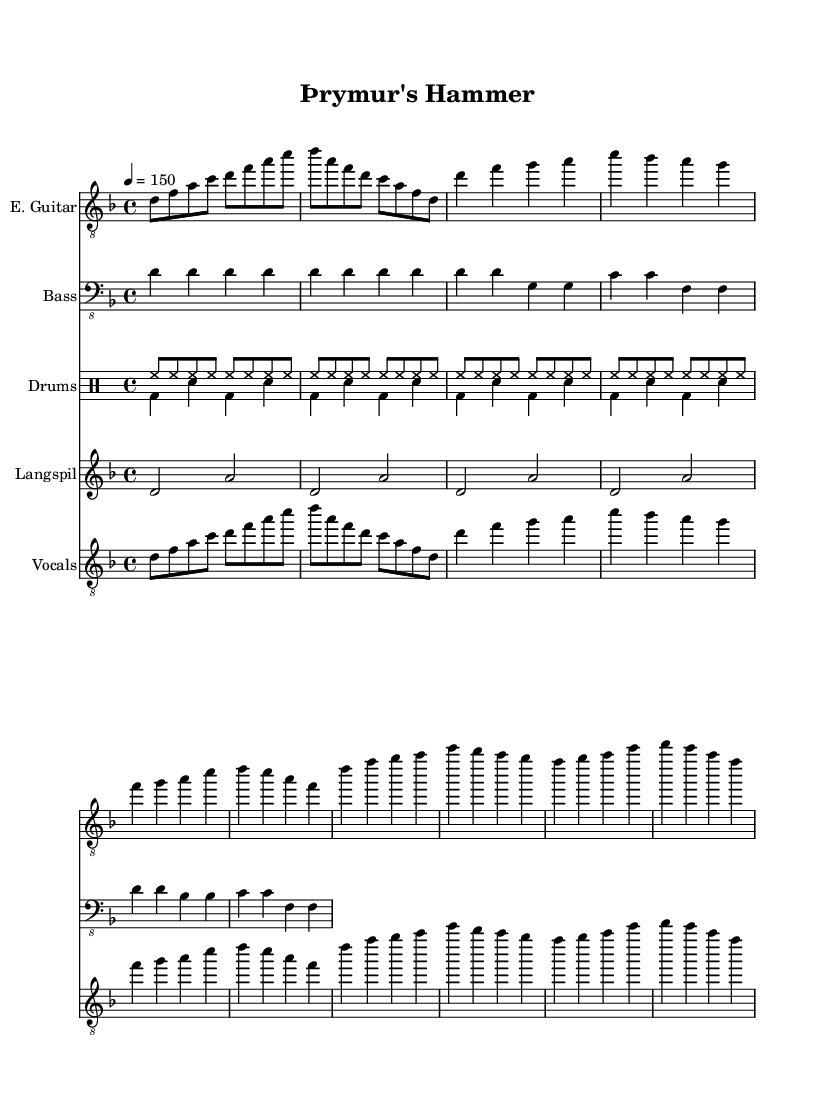What is the key signature of this music? The key signature is indicated at the beginning of the music with the sharp or flat symbols. In this case, it is D minor, which has one flat (B flat) and is noted in the header.
Answer: D minor What is the time signature of this music? The time signature is found at the beginning of the score, indicating how many beats are in each measure. Here, it shows 4/4, meaning there are four beats per measure.
Answer: 4/4 What is the tempo of the piece? The tempo marking is given in the global section, specifically indicating the beats per minute (BPM). It reads 4 = 150, meaning there are 150 beats per minute.
Answer: 150 How many measures are in the Intro section? By counting the grouped notes in the Intro section, we see that there are 4 measures total. Each measure is separated by a vertical line.
Answer: 4 What is the vocal theme of the song? The lyrics provided describe the theme of the song, which revolves around Thor and his hammer. This can be inferred from the words noted in the vocal section.
Answer: Thor's hammer What instrument is labeled "Langspil" in the score? The instrument labeled "Langspil" can be identified in the score under its respective staff. It refers to a traditional Icelandic string instrument designed for this composition.
Answer: Langspil What role does the drum pattern play in the piece? Analyzing the drum sections, we see that they add rhythmic support and intensity to the song, which is characteristic of metal music. The patterns are designed to drive the energy of the piece forward.
Answer: Rhythmic support 